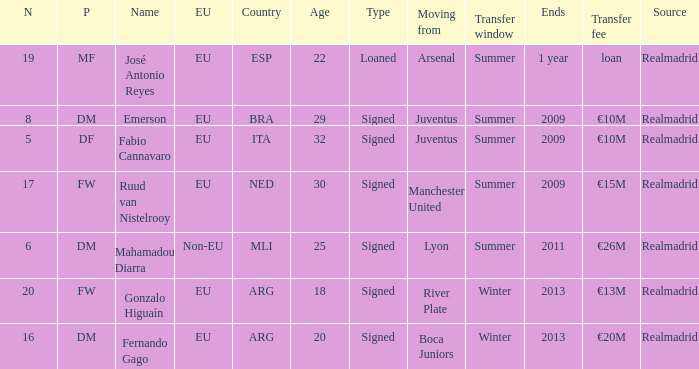How many numbers are ending in 1 year? 1.0. 